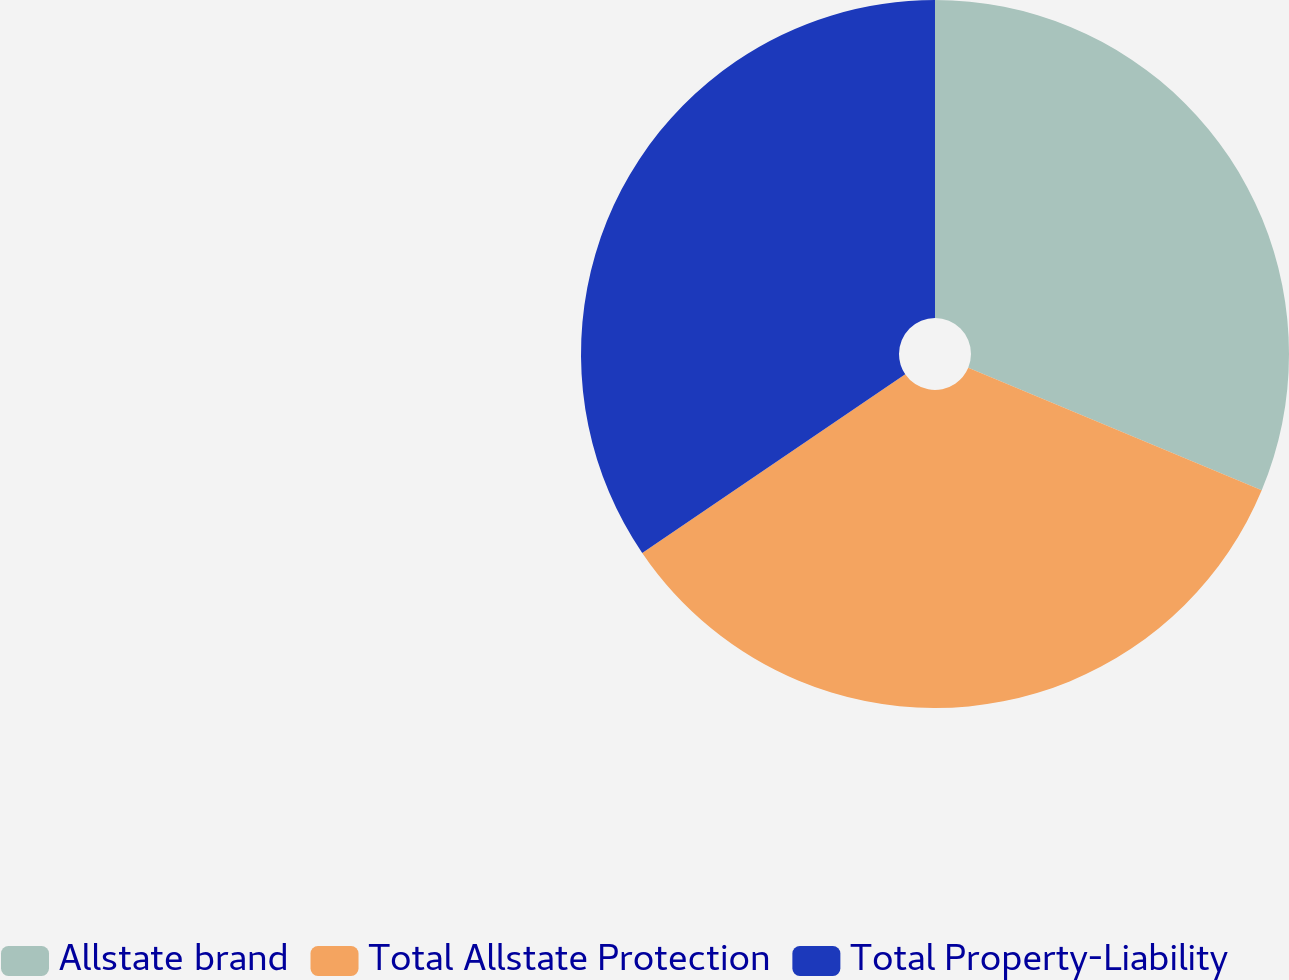Convert chart. <chart><loc_0><loc_0><loc_500><loc_500><pie_chart><fcel>Allstate brand<fcel>Total Allstate Protection<fcel>Total Property-Liability<nl><fcel>31.29%<fcel>34.21%<fcel>34.5%<nl></chart> 